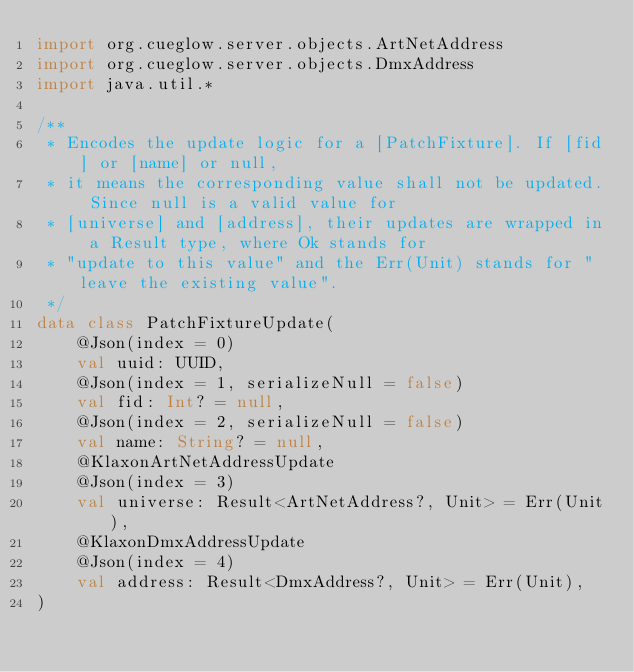<code> <loc_0><loc_0><loc_500><loc_500><_Kotlin_>import org.cueglow.server.objects.ArtNetAddress
import org.cueglow.server.objects.DmxAddress
import java.util.*

/**
 * Encodes the update logic for a [PatchFixture]. If [fid] or [name] or null,
 * it means the corresponding value shall not be updated. Since null is a valid value for
 * [universe] and [address], their updates are wrapped in a Result type, where Ok stands for
 * "update to this value" and the Err(Unit) stands for "leave the existing value".
 */
data class PatchFixtureUpdate(
    @Json(index = 0)
    val uuid: UUID,
    @Json(index = 1, serializeNull = false)
    val fid: Int? = null,
    @Json(index = 2, serializeNull = false)
    val name: String? = null,
    @KlaxonArtNetAddressUpdate
    @Json(index = 3)
    val universe: Result<ArtNetAddress?, Unit> = Err(Unit),
    @KlaxonDmxAddressUpdate
    @Json(index = 4)
    val address: Result<DmxAddress?, Unit> = Err(Unit),
)</code> 